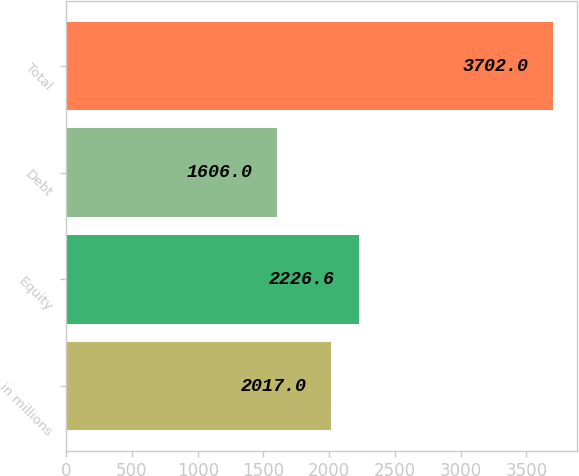<chart> <loc_0><loc_0><loc_500><loc_500><bar_chart><fcel>in millions<fcel>Equity<fcel>Debt<fcel>Total<nl><fcel>2017<fcel>2226.6<fcel>1606<fcel>3702<nl></chart> 